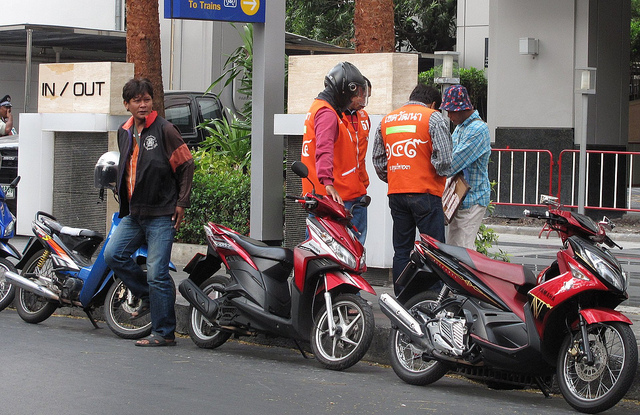<image>What is the color of the garbage can? There is no garbage can in the image. However, if there is, it could be a variety of colors including white, gray, silver, red, or black. What is the color of the garbage can? There is no garbage can in the image. 